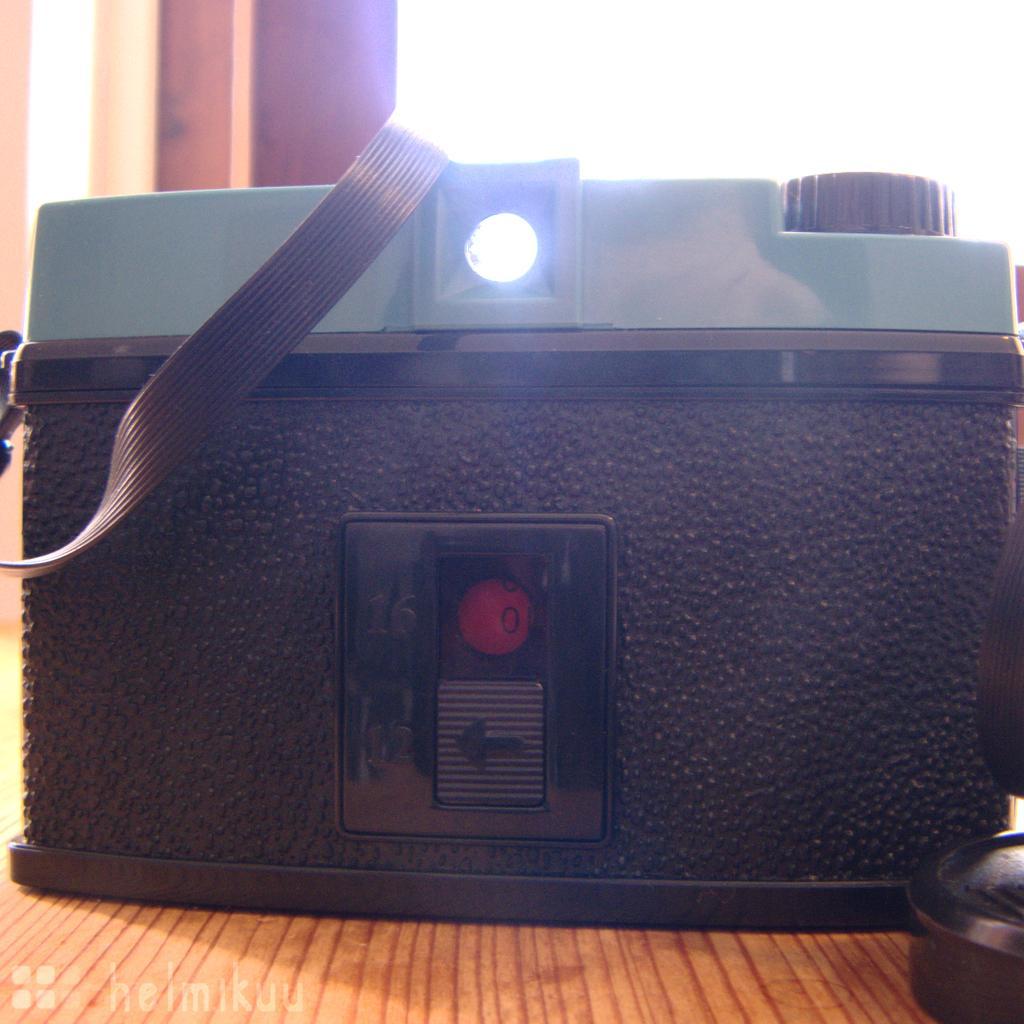Could you give a brief overview of what you see in this image? In this picture we can see a machine on the wooden object and behind the object there is a wall. On the image there is a watermark. 